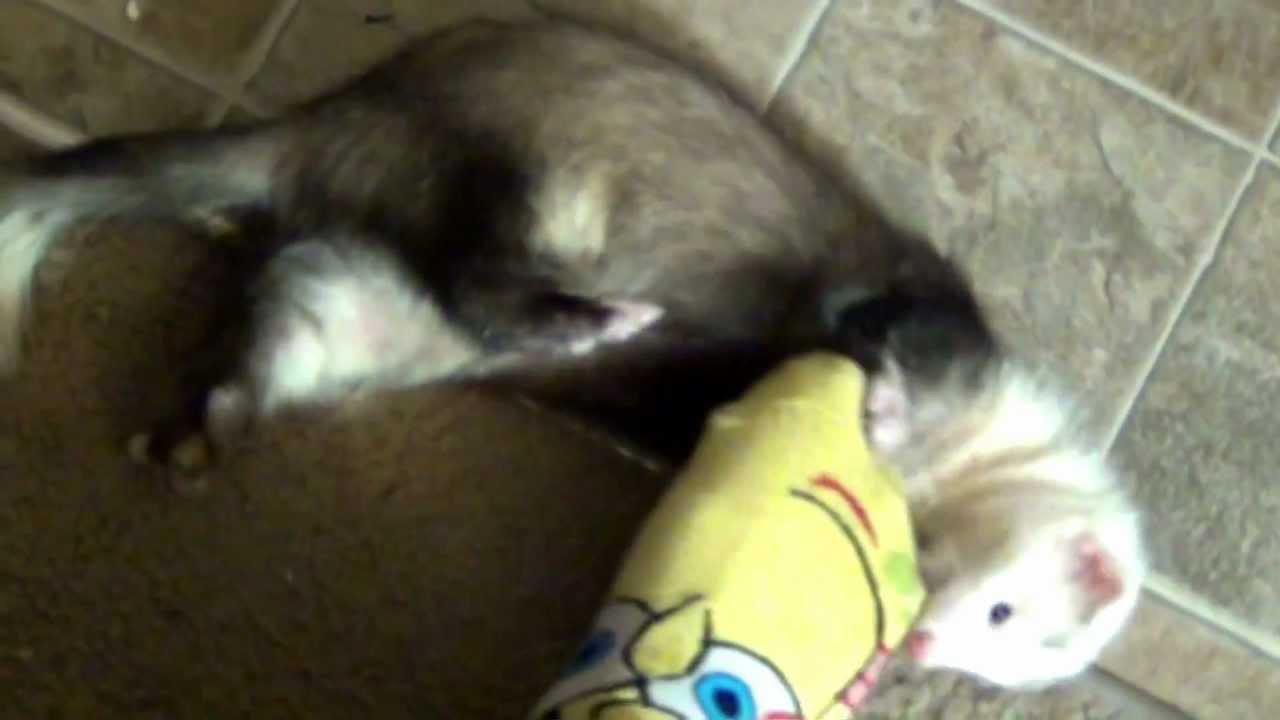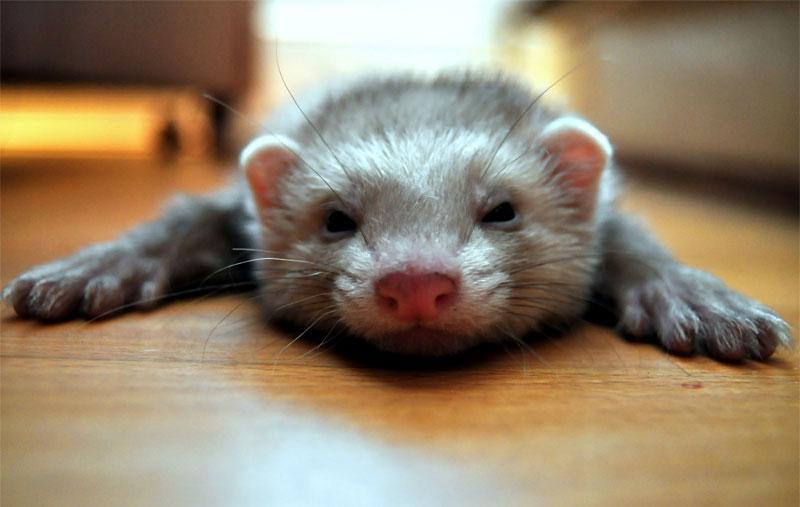The first image is the image on the left, the second image is the image on the right. Evaluate the accuracy of this statement regarding the images: "At least one ferret has an open mouth with tongue showing, and a total of three ferrets are shown.". Is it true? Answer yes or no. No. The first image is the image on the left, the second image is the image on the right. Examine the images to the left and right. Is the description "At least one of the ferrets has their tongue sticking out." accurate? Answer yes or no. No. 